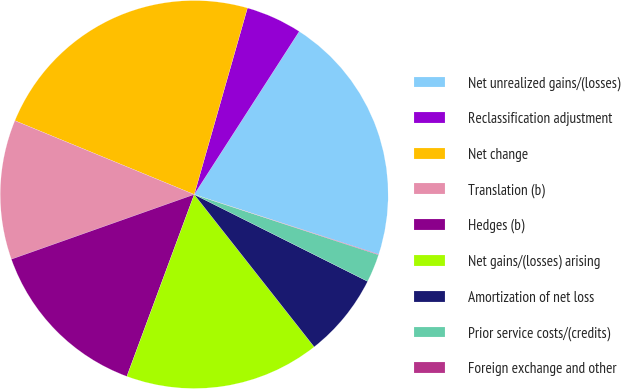<chart> <loc_0><loc_0><loc_500><loc_500><pie_chart><fcel>Net unrealized gains/(losses)<fcel>Reclassification adjustment<fcel>Net change<fcel>Translation (b)<fcel>Hedges (b)<fcel>Net gains/(losses) arising<fcel>Amortization of net loss<fcel>Prior service costs/(credits)<fcel>Foreign exchange and other<nl><fcel>20.89%<fcel>4.68%<fcel>23.21%<fcel>11.63%<fcel>13.94%<fcel>16.26%<fcel>6.99%<fcel>2.36%<fcel>0.04%<nl></chart> 